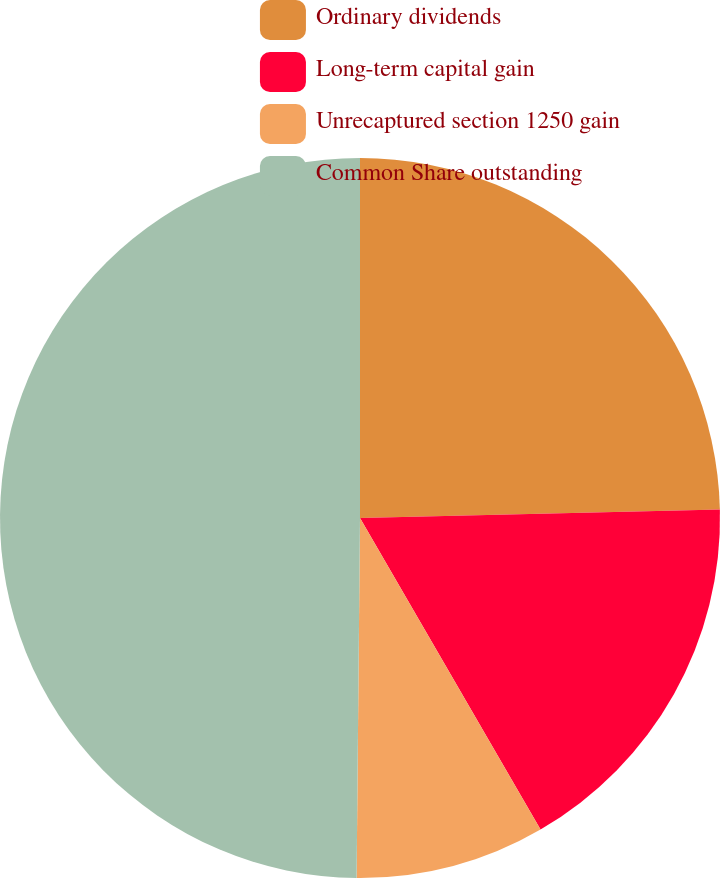Convert chart to OTSL. <chart><loc_0><loc_0><loc_500><loc_500><pie_chart><fcel>Ordinary dividends<fcel>Long-term capital gain<fcel>Unrecaptured section 1250 gain<fcel>Common Share outstanding<nl><fcel>24.62%<fcel>17.02%<fcel>8.51%<fcel>49.85%<nl></chart> 